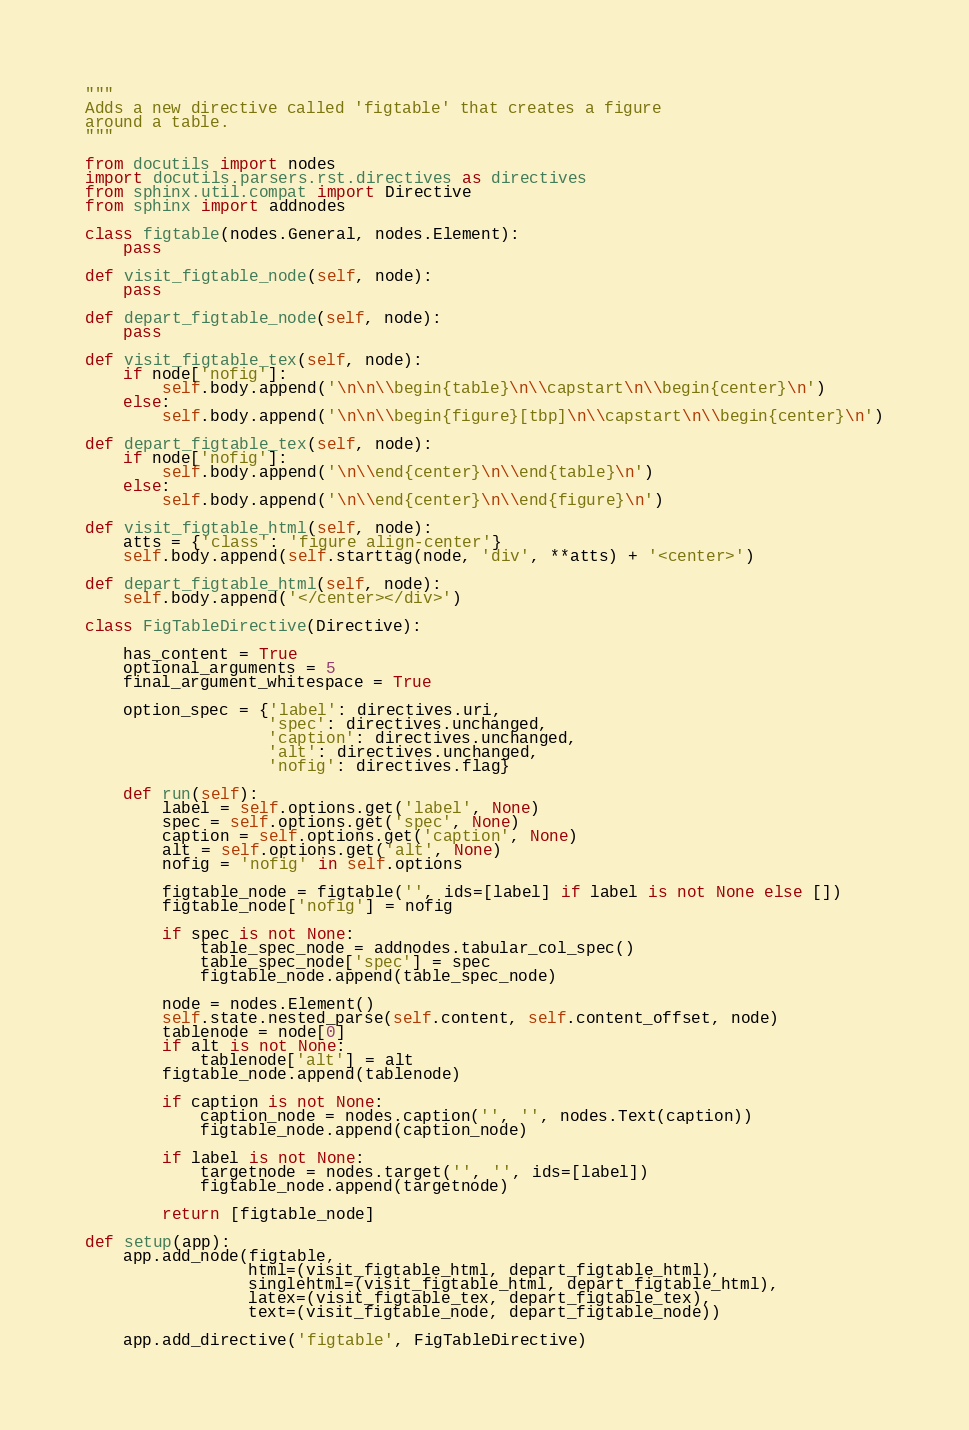Convert code to text. <code><loc_0><loc_0><loc_500><loc_500><_Python_>"""
Adds a new directive called 'figtable' that creates a figure
around a table.
"""

from docutils import nodes
import docutils.parsers.rst.directives as directives
from sphinx.util.compat import Directive
from sphinx import addnodes

class figtable(nodes.General, nodes.Element):
    pass

def visit_figtable_node(self, node):
    pass

def depart_figtable_node(self, node):
    pass

def visit_figtable_tex(self, node):
    if node['nofig']:
        self.body.append('\n\n\\begin{table}\n\\capstart\n\\begin{center}\n')
    else:
        self.body.append('\n\n\\begin{figure}[tbp]\n\\capstart\n\\begin{center}\n')

def depart_figtable_tex(self, node):
    if node['nofig']:
        self.body.append('\n\\end{center}\n\\end{table}\n')
    else:
        self.body.append('\n\\end{center}\n\\end{figure}\n')

def visit_figtable_html(self, node):
    atts = {'class': 'figure align-center'}
    self.body.append(self.starttag(node, 'div', **atts) + '<center>')

def depart_figtable_html(self, node):
    self.body.append('</center></div>')

class FigTableDirective(Directive):
    
    has_content = True
    optional_arguments = 5
    final_argument_whitespace = True

    option_spec = {'label': directives.uri,
                   'spec': directives.unchanged,
                   'caption': directives.unchanged,
                   'alt': directives.unchanged,
                   'nofig': directives.flag}

    def run(self):
        label = self.options.get('label', None)
        spec = self.options.get('spec', None)
        caption = self.options.get('caption', None)
        alt = self.options.get('alt', None)
        nofig = 'nofig' in self.options
        
        figtable_node = figtable('', ids=[label] if label is not None else [])
        figtable_node['nofig'] = nofig
        
        if spec is not None:
            table_spec_node = addnodes.tabular_col_spec()
            table_spec_node['spec'] = spec
            figtable_node.append(table_spec_node)
        
        node = nodes.Element()
        self.state.nested_parse(self.content, self.content_offset, node)
        tablenode = node[0]
        if alt is not None:
            tablenode['alt'] = alt
        figtable_node.append(tablenode)
        
        if caption is not None:
            caption_node = nodes.caption('', '', nodes.Text(caption))
            figtable_node.append(caption_node)
        
        if label is not None:
            targetnode = nodes.target('', '', ids=[label])
            figtable_node.append(targetnode)
        
        return [figtable_node]

def setup(app):
    app.add_node(figtable,
                 html=(visit_figtable_html, depart_figtable_html),
                 singlehtml=(visit_figtable_html, depart_figtable_html),
                 latex=(visit_figtable_tex, depart_figtable_tex),
                 text=(visit_figtable_node, depart_figtable_node))

    app.add_directive('figtable', FigTableDirective)
</code> 